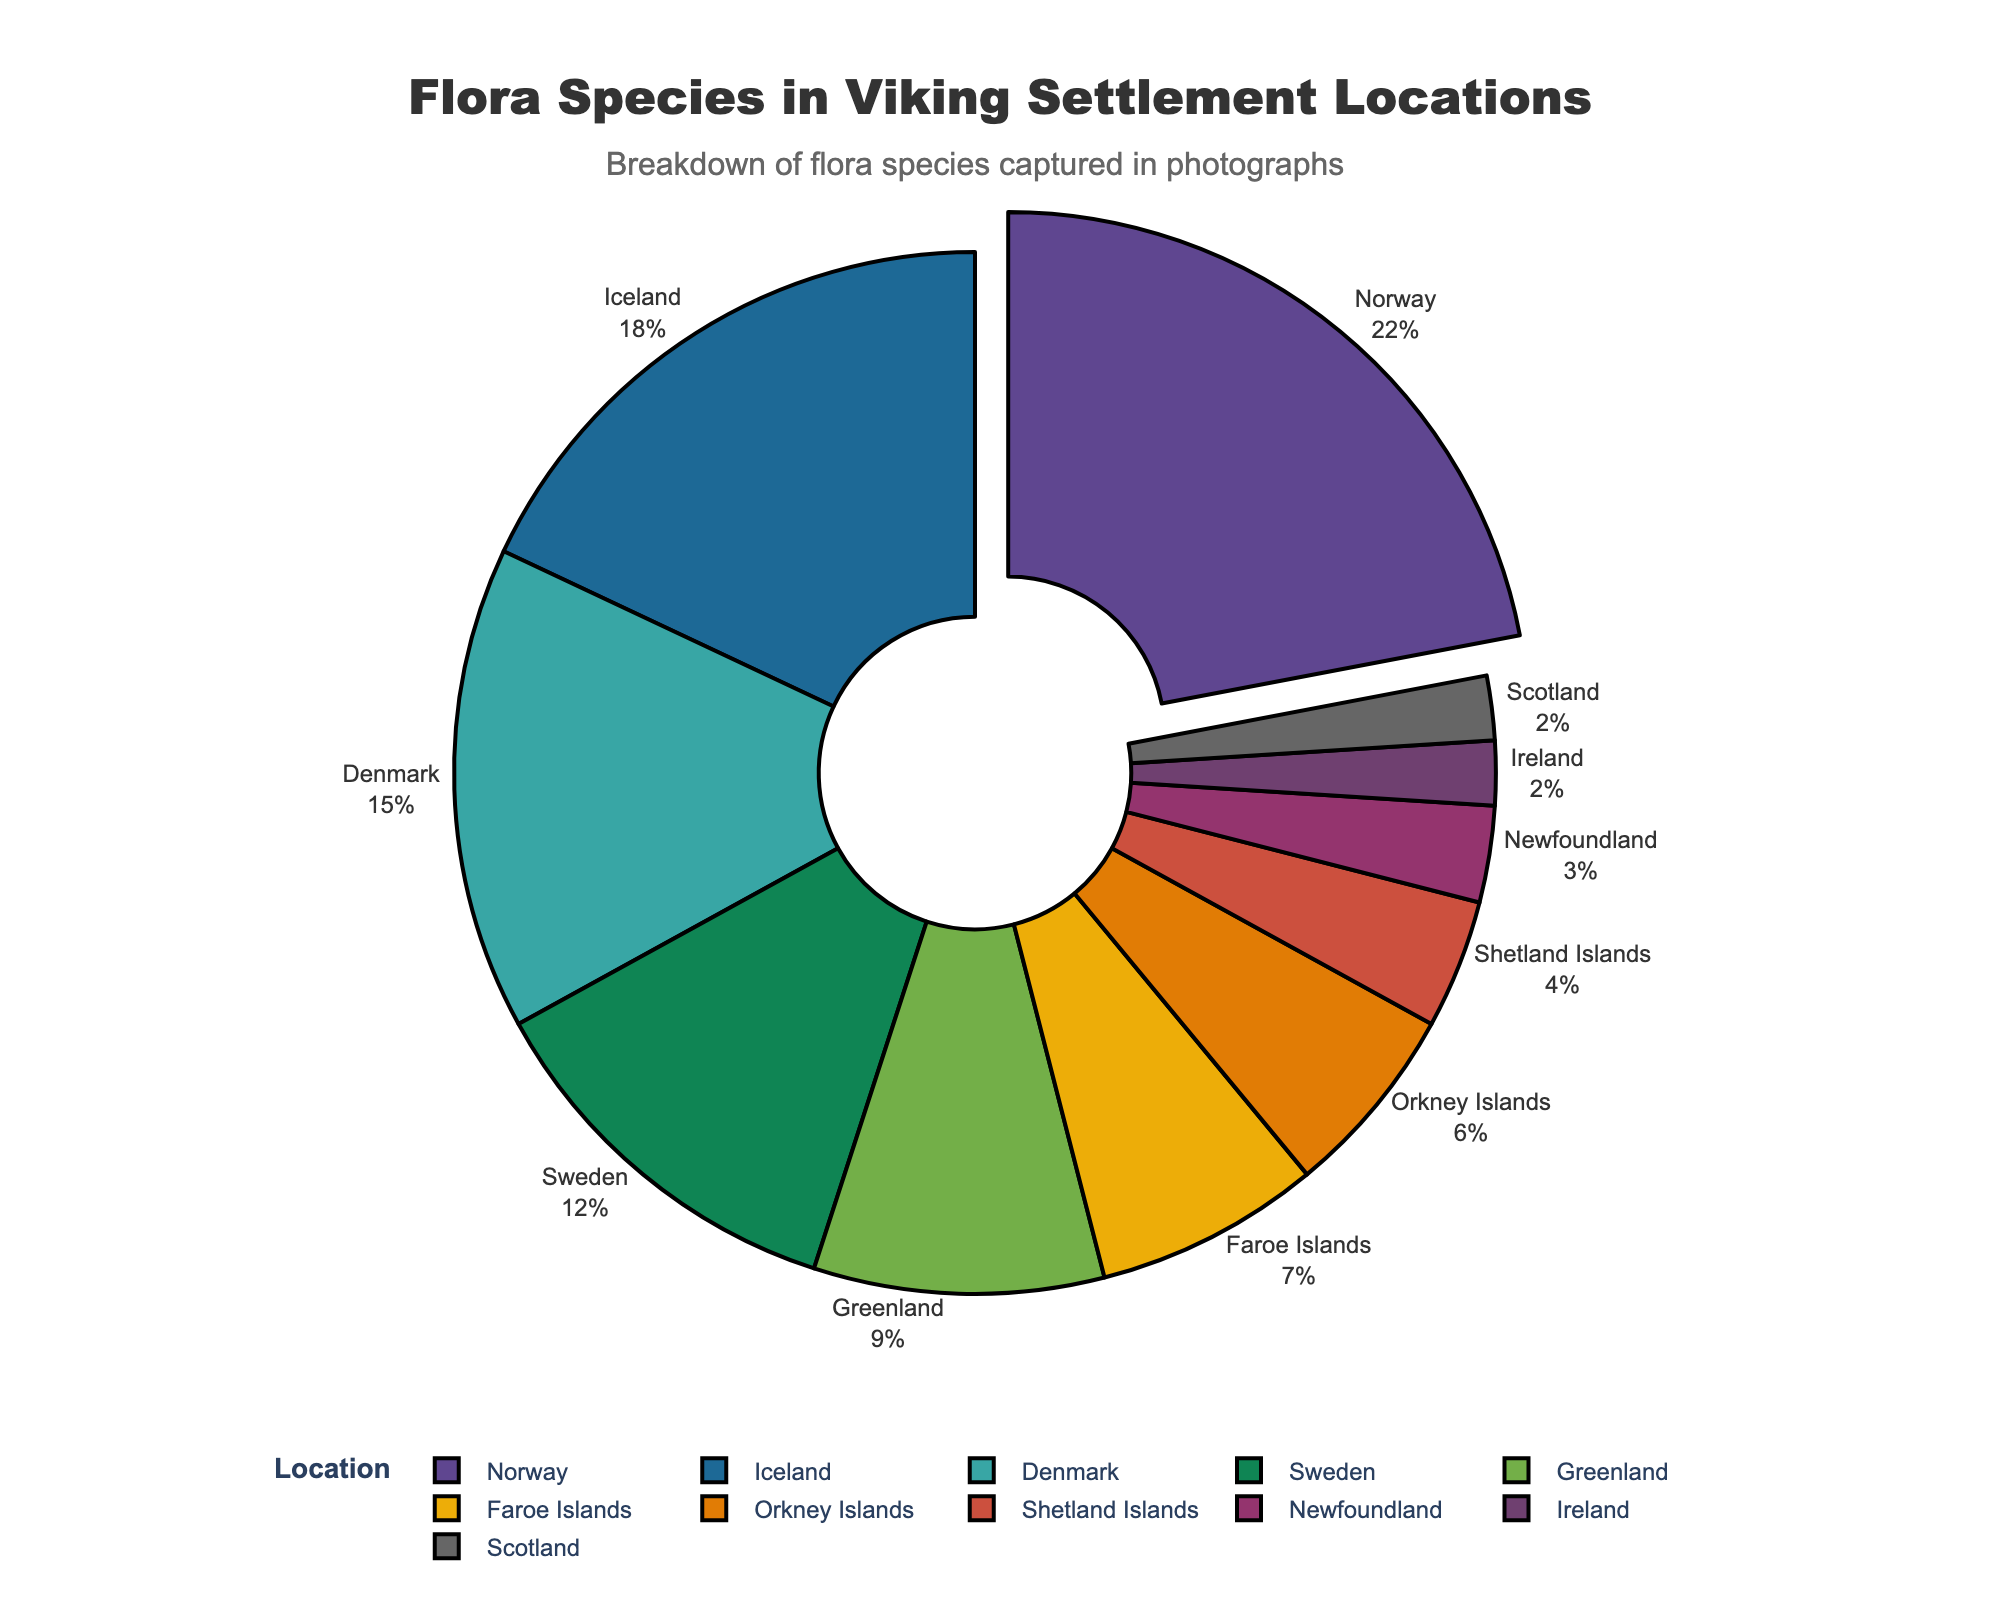What's the largest segment in the pie chart? The segment representing the location with the highest percentage will be the largest. Refer to the slice with the greatest size in the figure.
Answer: Scots Pine in Norway Which two locations have the smallest percentage of captured flora species? The chart shows multiple segments, the two smallest ones will be those with the least visible area. Look for the smallest slices in the pie chart.
Answer: Ireland and Scotland What's the percentage difference between Scots Pine in Norway and Sea Mayweed in Shetland Islands? Identify the percentages of both Scots Pine (22%) and Sea Mayweed (4%) and subtract the smaller percentage from the larger one: 22% - 4%.
Answer: 18% Which location contributes more to the captured flora species, the Orkney Islands or the Faroe Islands? Compare the percentages of Orkney Islands (6%) and Faroe Islands (7%). The larger percentage will indicate the location contributing more.
Answer: Faroe Islands What fraction of the pie chart does the Arctic Cotton Grass in Greenland represent? Divide the percentage of Arctic Cotton Grass (9%) by 100 to get the fraction.
Answer: 0.09 If you sum the percentages for Ireland, Scotland, and Newfoundland, what is the total? Sum up the percentages for Ireland (2%), Scotland (2%), and Newfoundland (3%): 2% + 2% + 3%.
Answer: 7% Among the locations, which one is highlighted by a pulled-out slice? The pulled-out slice indicates the maximum percentage. Identify the pulled-out slice in the pie chart.
Answer: Scots Pine in Norway Which location has a species representation closer to the median value of all percentages? To find the median, list all percentages and find the middle value. The middle value is 7% (after sorting: 2, 2, 3, 4, 6, 7, 9, 12, 15, 18, 22).
Answer: Faroe Islands Which species has a higher representation percentage, Heather in Orkney Islands or European Beech in Denmark? Compare percentages of Heather (6%) and European Beech (15%). The one with the larger percentage is higher.
Answer: European Beech in Denmark 